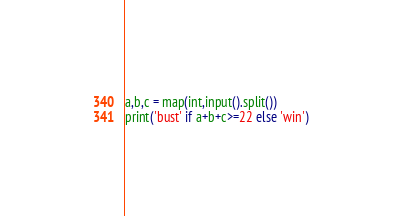Convert code to text. <code><loc_0><loc_0><loc_500><loc_500><_Python_>a,b,c = map(int,input().split())
print('bust' if a+b+c>=22 else 'win') </code> 